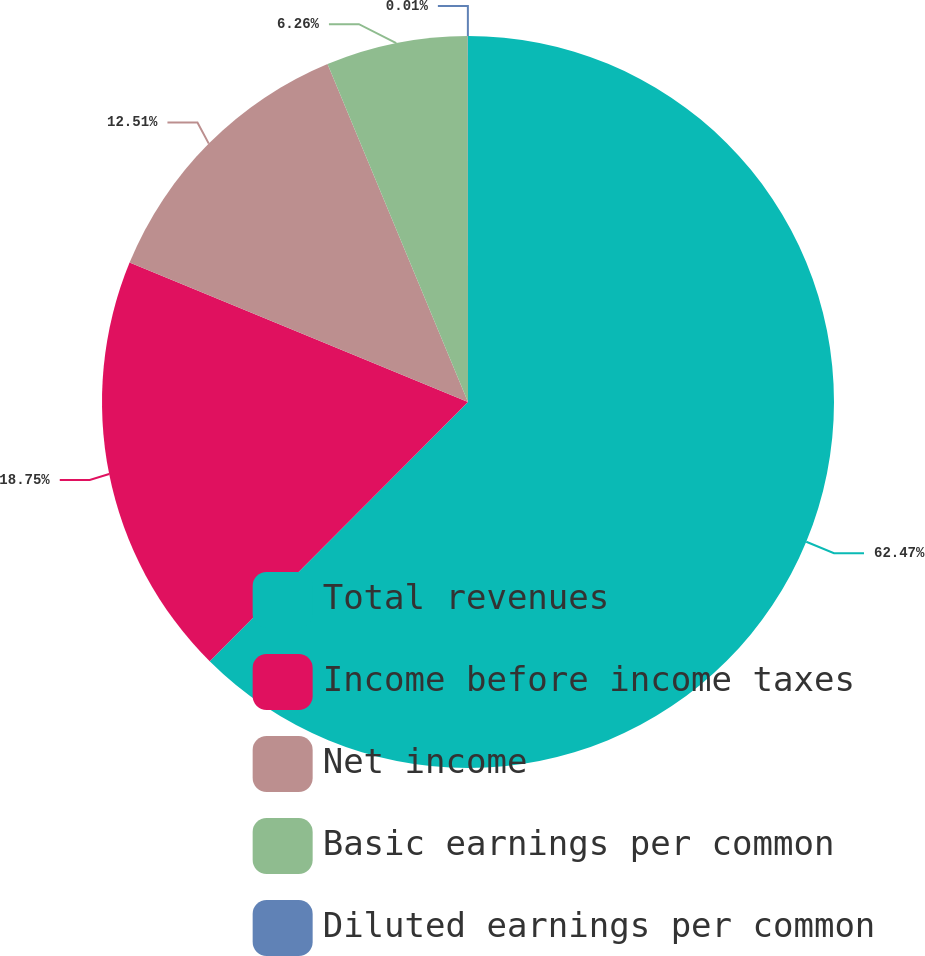Convert chart to OTSL. <chart><loc_0><loc_0><loc_500><loc_500><pie_chart><fcel>Total revenues<fcel>Income before income taxes<fcel>Net income<fcel>Basic earnings per common<fcel>Diluted earnings per common<nl><fcel>62.47%<fcel>18.75%<fcel>12.51%<fcel>6.26%<fcel>0.01%<nl></chart> 